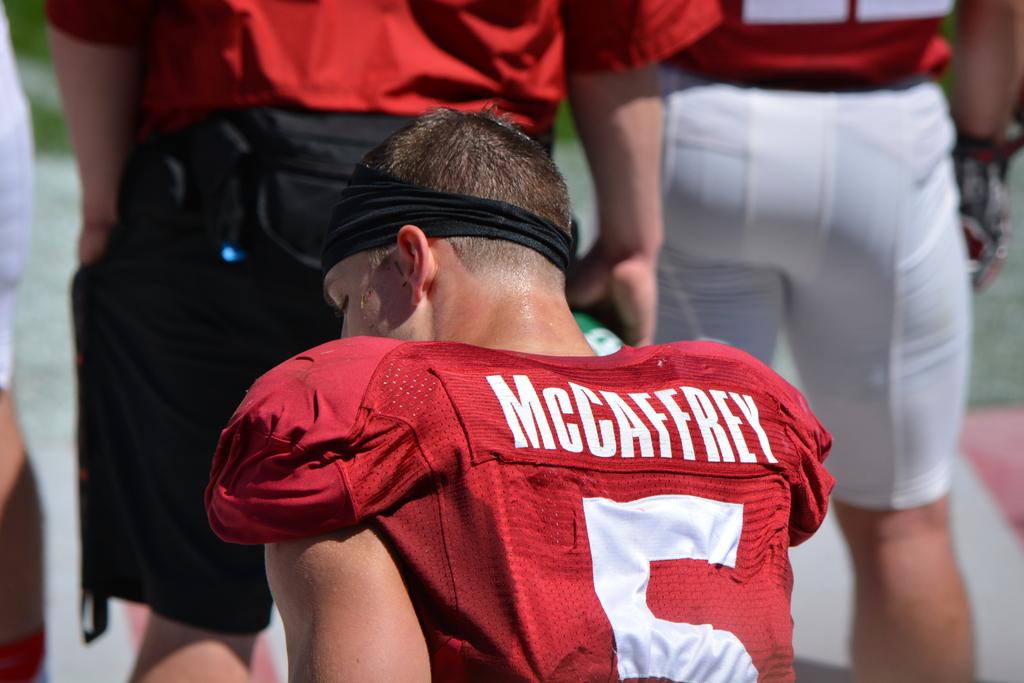What is the players name?
Your response must be concise. Mccaffrey. 